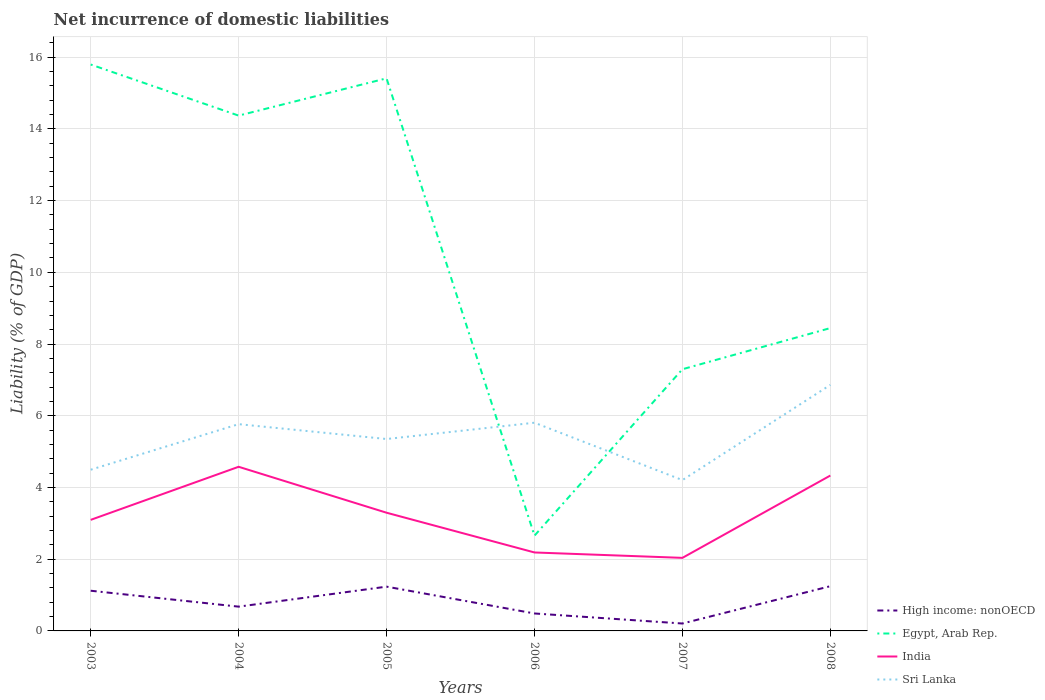Does the line corresponding to Sri Lanka intersect with the line corresponding to High income: nonOECD?
Your response must be concise. No. Across all years, what is the maximum net incurrence of domestic liabilities in High income: nonOECD?
Provide a succinct answer. 0.21. What is the total net incurrence of domestic liabilities in High income: nonOECD in the graph?
Give a very brief answer. 0.75. What is the difference between the highest and the second highest net incurrence of domestic liabilities in High income: nonOECD?
Keep it short and to the point. 1.04. What is the difference between the highest and the lowest net incurrence of domestic liabilities in India?
Offer a terse response. 3. Is the net incurrence of domestic liabilities in India strictly greater than the net incurrence of domestic liabilities in Egypt, Arab Rep. over the years?
Offer a terse response. Yes. How many lines are there?
Make the answer very short. 4. How many years are there in the graph?
Your answer should be very brief. 6. Are the values on the major ticks of Y-axis written in scientific E-notation?
Provide a succinct answer. No. Does the graph contain any zero values?
Make the answer very short. No. What is the title of the graph?
Keep it short and to the point. Net incurrence of domestic liabilities. What is the label or title of the Y-axis?
Ensure brevity in your answer.  Liability (% of GDP). What is the Liability (% of GDP) in High income: nonOECD in 2003?
Make the answer very short. 1.12. What is the Liability (% of GDP) in Egypt, Arab Rep. in 2003?
Give a very brief answer. 15.79. What is the Liability (% of GDP) of India in 2003?
Provide a short and direct response. 3.1. What is the Liability (% of GDP) of Sri Lanka in 2003?
Your answer should be compact. 4.5. What is the Liability (% of GDP) of High income: nonOECD in 2004?
Your answer should be very brief. 0.68. What is the Liability (% of GDP) of Egypt, Arab Rep. in 2004?
Provide a short and direct response. 14.37. What is the Liability (% of GDP) in India in 2004?
Your response must be concise. 4.58. What is the Liability (% of GDP) in Sri Lanka in 2004?
Give a very brief answer. 5.77. What is the Liability (% of GDP) in High income: nonOECD in 2005?
Give a very brief answer. 1.23. What is the Liability (% of GDP) in Egypt, Arab Rep. in 2005?
Provide a short and direct response. 15.41. What is the Liability (% of GDP) in India in 2005?
Make the answer very short. 3.3. What is the Liability (% of GDP) in Sri Lanka in 2005?
Provide a short and direct response. 5.35. What is the Liability (% of GDP) in High income: nonOECD in 2006?
Keep it short and to the point. 0.49. What is the Liability (% of GDP) in Egypt, Arab Rep. in 2006?
Give a very brief answer. 2.66. What is the Liability (% of GDP) of India in 2006?
Give a very brief answer. 2.19. What is the Liability (% of GDP) in Sri Lanka in 2006?
Ensure brevity in your answer.  5.81. What is the Liability (% of GDP) of High income: nonOECD in 2007?
Your response must be concise. 0.21. What is the Liability (% of GDP) of Egypt, Arab Rep. in 2007?
Provide a succinct answer. 7.3. What is the Liability (% of GDP) in India in 2007?
Offer a terse response. 2.04. What is the Liability (% of GDP) in Sri Lanka in 2007?
Offer a terse response. 4.21. What is the Liability (% of GDP) of High income: nonOECD in 2008?
Offer a terse response. 1.25. What is the Liability (% of GDP) in Egypt, Arab Rep. in 2008?
Your answer should be very brief. 8.45. What is the Liability (% of GDP) in India in 2008?
Offer a terse response. 4.33. What is the Liability (% of GDP) of Sri Lanka in 2008?
Provide a short and direct response. 6.86. Across all years, what is the maximum Liability (% of GDP) in High income: nonOECD?
Give a very brief answer. 1.25. Across all years, what is the maximum Liability (% of GDP) in Egypt, Arab Rep.?
Give a very brief answer. 15.79. Across all years, what is the maximum Liability (% of GDP) of India?
Provide a succinct answer. 4.58. Across all years, what is the maximum Liability (% of GDP) of Sri Lanka?
Offer a very short reply. 6.86. Across all years, what is the minimum Liability (% of GDP) in High income: nonOECD?
Provide a short and direct response. 0.21. Across all years, what is the minimum Liability (% of GDP) in Egypt, Arab Rep.?
Provide a short and direct response. 2.66. Across all years, what is the minimum Liability (% of GDP) of India?
Provide a succinct answer. 2.04. Across all years, what is the minimum Liability (% of GDP) in Sri Lanka?
Your response must be concise. 4.21. What is the total Liability (% of GDP) of High income: nonOECD in the graph?
Your answer should be compact. 4.97. What is the total Liability (% of GDP) of Egypt, Arab Rep. in the graph?
Make the answer very short. 63.97. What is the total Liability (% of GDP) in India in the graph?
Your answer should be compact. 19.53. What is the total Liability (% of GDP) in Sri Lanka in the graph?
Offer a terse response. 32.49. What is the difference between the Liability (% of GDP) of High income: nonOECD in 2003 and that in 2004?
Your answer should be very brief. 0.44. What is the difference between the Liability (% of GDP) in Egypt, Arab Rep. in 2003 and that in 2004?
Your answer should be compact. 1.42. What is the difference between the Liability (% of GDP) in India in 2003 and that in 2004?
Provide a succinct answer. -1.48. What is the difference between the Liability (% of GDP) of Sri Lanka in 2003 and that in 2004?
Offer a very short reply. -1.27. What is the difference between the Liability (% of GDP) of High income: nonOECD in 2003 and that in 2005?
Provide a short and direct response. -0.11. What is the difference between the Liability (% of GDP) in Egypt, Arab Rep. in 2003 and that in 2005?
Ensure brevity in your answer.  0.39. What is the difference between the Liability (% of GDP) of India in 2003 and that in 2005?
Provide a short and direct response. -0.2. What is the difference between the Liability (% of GDP) in Sri Lanka in 2003 and that in 2005?
Provide a short and direct response. -0.86. What is the difference between the Liability (% of GDP) in High income: nonOECD in 2003 and that in 2006?
Your answer should be very brief. 0.63. What is the difference between the Liability (% of GDP) in Egypt, Arab Rep. in 2003 and that in 2006?
Give a very brief answer. 13.14. What is the difference between the Liability (% of GDP) of India in 2003 and that in 2006?
Make the answer very short. 0.91. What is the difference between the Liability (% of GDP) of Sri Lanka in 2003 and that in 2006?
Your response must be concise. -1.31. What is the difference between the Liability (% of GDP) in High income: nonOECD in 2003 and that in 2007?
Ensure brevity in your answer.  0.91. What is the difference between the Liability (% of GDP) in Egypt, Arab Rep. in 2003 and that in 2007?
Ensure brevity in your answer.  8.5. What is the difference between the Liability (% of GDP) of India in 2003 and that in 2007?
Ensure brevity in your answer.  1.06. What is the difference between the Liability (% of GDP) of Sri Lanka in 2003 and that in 2007?
Offer a terse response. 0.29. What is the difference between the Liability (% of GDP) of High income: nonOECD in 2003 and that in 2008?
Your answer should be compact. -0.13. What is the difference between the Liability (% of GDP) in Egypt, Arab Rep. in 2003 and that in 2008?
Offer a very short reply. 7.35. What is the difference between the Liability (% of GDP) in India in 2003 and that in 2008?
Your answer should be very brief. -1.24. What is the difference between the Liability (% of GDP) in Sri Lanka in 2003 and that in 2008?
Make the answer very short. -2.37. What is the difference between the Liability (% of GDP) in High income: nonOECD in 2004 and that in 2005?
Your response must be concise. -0.56. What is the difference between the Liability (% of GDP) in Egypt, Arab Rep. in 2004 and that in 2005?
Make the answer very short. -1.04. What is the difference between the Liability (% of GDP) in India in 2004 and that in 2005?
Your answer should be compact. 1.28. What is the difference between the Liability (% of GDP) of Sri Lanka in 2004 and that in 2005?
Provide a short and direct response. 0.41. What is the difference between the Liability (% of GDP) in High income: nonOECD in 2004 and that in 2006?
Your response must be concise. 0.19. What is the difference between the Liability (% of GDP) of Egypt, Arab Rep. in 2004 and that in 2006?
Ensure brevity in your answer.  11.71. What is the difference between the Liability (% of GDP) in India in 2004 and that in 2006?
Offer a very short reply. 2.39. What is the difference between the Liability (% of GDP) in Sri Lanka in 2004 and that in 2006?
Keep it short and to the point. -0.04. What is the difference between the Liability (% of GDP) in High income: nonOECD in 2004 and that in 2007?
Provide a short and direct response. 0.47. What is the difference between the Liability (% of GDP) in Egypt, Arab Rep. in 2004 and that in 2007?
Ensure brevity in your answer.  7.07. What is the difference between the Liability (% of GDP) of India in 2004 and that in 2007?
Give a very brief answer. 2.54. What is the difference between the Liability (% of GDP) in Sri Lanka in 2004 and that in 2007?
Give a very brief answer. 1.56. What is the difference between the Liability (% of GDP) in High income: nonOECD in 2004 and that in 2008?
Provide a succinct answer. -0.57. What is the difference between the Liability (% of GDP) of Egypt, Arab Rep. in 2004 and that in 2008?
Ensure brevity in your answer.  5.93. What is the difference between the Liability (% of GDP) in India in 2004 and that in 2008?
Your answer should be very brief. 0.24. What is the difference between the Liability (% of GDP) of Sri Lanka in 2004 and that in 2008?
Your answer should be very brief. -1.1. What is the difference between the Liability (% of GDP) of High income: nonOECD in 2005 and that in 2006?
Offer a terse response. 0.75. What is the difference between the Liability (% of GDP) of Egypt, Arab Rep. in 2005 and that in 2006?
Give a very brief answer. 12.75. What is the difference between the Liability (% of GDP) in India in 2005 and that in 2006?
Your answer should be very brief. 1.11. What is the difference between the Liability (% of GDP) of Sri Lanka in 2005 and that in 2006?
Your answer should be very brief. -0.45. What is the difference between the Liability (% of GDP) of High income: nonOECD in 2005 and that in 2007?
Your answer should be very brief. 1.03. What is the difference between the Liability (% of GDP) in Egypt, Arab Rep. in 2005 and that in 2007?
Keep it short and to the point. 8.11. What is the difference between the Liability (% of GDP) of India in 2005 and that in 2007?
Give a very brief answer. 1.26. What is the difference between the Liability (% of GDP) of Sri Lanka in 2005 and that in 2007?
Provide a succinct answer. 1.15. What is the difference between the Liability (% of GDP) of High income: nonOECD in 2005 and that in 2008?
Ensure brevity in your answer.  -0.01. What is the difference between the Liability (% of GDP) in Egypt, Arab Rep. in 2005 and that in 2008?
Your answer should be compact. 6.96. What is the difference between the Liability (% of GDP) of India in 2005 and that in 2008?
Provide a short and direct response. -1.04. What is the difference between the Liability (% of GDP) in Sri Lanka in 2005 and that in 2008?
Offer a terse response. -1.51. What is the difference between the Liability (% of GDP) of High income: nonOECD in 2006 and that in 2007?
Make the answer very short. 0.28. What is the difference between the Liability (% of GDP) of Egypt, Arab Rep. in 2006 and that in 2007?
Offer a terse response. -4.64. What is the difference between the Liability (% of GDP) in India in 2006 and that in 2007?
Offer a very short reply. 0.15. What is the difference between the Liability (% of GDP) in High income: nonOECD in 2006 and that in 2008?
Offer a very short reply. -0.76. What is the difference between the Liability (% of GDP) of Egypt, Arab Rep. in 2006 and that in 2008?
Make the answer very short. -5.79. What is the difference between the Liability (% of GDP) of India in 2006 and that in 2008?
Your response must be concise. -2.15. What is the difference between the Liability (% of GDP) in Sri Lanka in 2006 and that in 2008?
Offer a terse response. -1.06. What is the difference between the Liability (% of GDP) of High income: nonOECD in 2007 and that in 2008?
Your response must be concise. -1.04. What is the difference between the Liability (% of GDP) of Egypt, Arab Rep. in 2007 and that in 2008?
Give a very brief answer. -1.15. What is the difference between the Liability (% of GDP) in India in 2007 and that in 2008?
Keep it short and to the point. -2.3. What is the difference between the Liability (% of GDP) in Sri Lanka in 2007 and that in 2008?
Keep it short and to the point. -2.66. What is the difference between the Liability (% of GDP) of High income: nonOECD in 2003 and the Liability (% of GDP) of Egypt, Arab Rep. in 2004?
Your answer should be compact. -13.25. What is the difference between the Liability (% of GDP) of High income: nonOECD in 2003 and the Liability (% of GDP) of India in 2004?
Keep it short and to the point. -3.46. What is the difference between the Liability (% of GDP) of High income: nonOECD in 2003 and the Liability (% of GDP) of Sri Lanka in 2004?
Make the answer very short. -4.65. What is the difference between the Liability (% of GDP) in Egypt, Arab Rep. in 2003 and the Liability (% of GDP) in India in 2004?
Provide a short and direct response. 11.22. What is the difference between the Liability (% of GDP) in Egypt, Arab Rep. in 2003 and the Liability (% of GDP) in Sri Lanka in 2004?
Give a very brief answer. 10.03. What is the difference between the Liability (% of GDP) in India in 2003 and the Liability (% of GDP) in Sri Lanka in 2004?
Make the answer very short. -2.67. What is the difference between the Liability (% of GDP) in High income: nonOECD in 2003 and the Liability (% of GDP) in Egypt, Arab Rep. in 2005?
Your answer should be very brief. -14.29. What is the difference between the Liability (% of GDP) in High income: nonOECD in 2003 and the Liability (% of GDP) in India in 2005?
Your answer should be very brief. -2.18. What is the difference between the Liability (% of GDP) of High income: nonOECD in 2003 and the Liability (% of GDP) of Sri Lanka in 2005?
Provide a succinct answer. -4.23. What is the difference between the Liability (% of GDP) in Egypt, Arab Rep. in 2003 and the Liability (% of GDP) in India in 2005?
Give a very brief answer. 12.5. What is the difference between the Liability (% of GDP) of Egypt, Arab Rep. in 2003 and the Liability (% of GDP) of Sri Lanka in 2005?
Ensure brevity in your answer.  10.44. What is the difference between the Liability (% of GDP) in India in 2003 and the Liability (% of GDP) in Sri Lanka in 2005?
Provide a short and direct response. -2.25. What is the difference between the Liability (% of GDP) of High income: nonOECD in 2003 and the Liability (% of GDP) of Egypt, Arab Rep. in 2006?
Your response must be concise. -1.54. What is the difference between the Liability (% of GDP) of High income: nonOECD in 2003 and the Liability (% of GDP) of India in 2006?
Offer a terse response. -1.07. What is the difference between the Liability (% of GDP) of High income: nonOECD in 2003 and the Liability (% of GDP) of Sri Lanka in 2006?
Offer a terse response. -4.69. What is the difference between the Liability (% of GDP) in Egypt, Arab Rep. in 2003 and the Liability (% of GDP) in India in 2006?
Your response must be concise. 13.61. What is the difference between the Liability (% of GDP) of Egypt, Arab Rep. in 2003 and the Liability (% of GDP) of Sri Lanka in 2006?
Your response must be concise. 9.99. What is the difference between the Liability (% of GDP) of India in 2003 and the Liability (% of GDP) of Sri Lanka in 2006?
Your response must be concise. -2.71. What is the difference between the Liability (% of GDP) in High income: nonOECD in 2003 and the Liability (% of GDP) in Egypt, Arab Rep. in 2007?
Offer a terse response. -6.18. What is the difference between the Liability (% of GDP) in High income: nonOECD in 2003 and the Liability (% of GDP) in India in 2007?
Provide a succinct answer. -0.92. What is the difference between the Liability (% of GDP) in High income: nonOECD in 2003 and the Liability (% of GDP) in Sri Lanka in 2007?
Make the answer very short. -3.09. What is the difference between the Liability (% of GDP) of Egypt, Arab Rep. in 2003 and the Liability (% of GDP) of India in 2007?
Keep it short and to the point. 13.76. What is the difference between the Liability (% of GDP) in Egypt, Arab Rep. in 2003 and the Liability (% of GDP) in Sri Lanka in 2007?
Your answer should be compact. 11.59. What is the difference between the Liability (% of GDP) of India in 2003 and the Liability (% of GDP) of Sri Lanka in 2007?
Make the answer very short. -1.11. What is the difference between the Liability (% of GDP) in High income: nonOECD in 2003 and the Liability (% of GDP) in Egypt, Arab Rep. in 2008?
Ensure brevity in your answer.  -7.32. What is the difference between the Liability (% of GDP) of High income: nonOECD in 2003 and the Liability (% of GDP) of India in 2008?
Make the answer very short. -3.21. What is the difference between the Liability (% of GDP) of High income: nonOECD in 2003 and the Liability (% of GDP) of Sri Lanka in 2008?
Offer a terse response. -5.74. What is the difference between the Liability (% of GDP) in Egypt, Arab Rep. in 2003 and the Liability (% of GDP) in India in 2008?
Give a very brief answer. 11.46. What is the difference between the Liability (% of GDP) in Egypt, Arab Rep. in 2003 and the Liability (% of GDP) in Sri Lanka in 2008?
Make the answer very short. 8.93. What is the difference between the Liability (% of GDP) in India in 2003 and the Liability (% of GDP) in Sri Lanka in 2008?
Give a very brief answer. -3.76. What is the difference between the Liability (% of GDP) in High income: nonOECD in 2004 and the Liability (% of GDP) in Egypt, Arab Rep. in 2005?
Ensure brevity in your answer.  -14.73. What is the difference between the Liability (% of GDP) of High income: nonOECD in 2004 and the Liability (% of GDP) of India in 2005?
Ensure brevity in your answer.  -2.62. What is the difference between the Liability (% of GDP) of High income: nonOECD in 2004 and the Liability (% of GDP) of Sri Lanka in 2005?
Your response must be concise. -4.67. What is the difference between the Liability (% of GDP) of Egypt, Arab Rep. in 2004 and the Liability (% of GDP) of India in 2005?
Your answer should be compact. 11.07. What is the difference between the Liability (% of GDP) in Egypt, Arab Rep. in 2004 and the Liability (% of GDP) in Sri Lanka in 2005?
Ensure brevity in your answer.  9.02. What is the difference between the Liability (% of GDP) in India in 2004 and the Liability (% of GDP) in Sri Lanka in 2005?
Your answer should be very brief. -0.77. What is the difference between the Liability (% of GDP) in High income: nonOECD in 2004 and the Liability (% of GDP) in Egypt, Arab Rep. in 2006?
Your answer should be very brief. -1.98. What is the difference between the Liability (% of GDP) in High income: nonOECD in 2004 and the Liability (% of GDP) in India in 2006?
Offer a very short reply. -1.51. What is the difference between the Liability (% of GDP) in High income: nonOECD in 2004 and the Liability (% of GDP) in Sri Lanka in 2006?
Offer a very short reply. -5.13. What is the difference between the Liability (% of GDP) in Egypt, Arab Rep. in 2004 and the Liability (% of GDP) in India in 2006?
Your answer should be very brief. 12.18. What is the difference between the Liability (% of GDP) of Egypt, Arab Rep. in 2004 and the Liability (% of GDP) of Sri Lanka in 2006?
Ensure brevity in your answer.  8.56. What is the difference between the Liability (% of GDP) in India in 2004 and the Liability (% of GDP) in Sri Lanka in 2006?
Your answer should be very brief. -1.23. What is the difference between the Liability (% of GDP) of High income: nonOECD in 2004 and the Liability (% of GDP) of Egypt, Arab Rep. in 2007?
Give a very brief answer. -6.62. What is the difference between the Liability (% of GDP) of High income: nonOECD in 2004 and the Liability (% of GDP) of India in 2007?
Your answer should be compact. -1.36. What is the difference between the Liability (% of GDP) of High income: nonOECD in 2004 and the Liability (% of GDP) of Sri Lanka in 2007?
Offer a very short reply. -3.53. What is the difference between the Liability (% of GDP) of Egypt, Arab Rep. in 2004 and the Liability (% of GDP) of India in 2007?
Your answer should be very brief. 12.33. What is the difference between the Liability (% of GDP) of Egypt, Arab Rep. in 2004 and the Liability (% of GDP) of Sri Lanka in 2007?
Offer a terse response. 10.16. What is the difference between the Liability (% of GDP) of India in 2004 and the Liability (% of GDP) of Sri Lanka in 2007?
Offer a terse response. 0.37. What is the difference between the Liability (% of GDP) in High income: nonOECD in 2004 and the Liability (% of GDP) in Egypt, Arab Rep. in 2008?
Ensure brevity in your answer.  -7.77. What is the difference between the Liability (% of GDP) in High income: nonOECD in 2004 and the Liability (% of GDP) in India in 2008?
Ensure brevity in your answer.  -3.66. What is the difference between the Liability (% of GDP) in High income: nonOECD in 2004 and the Liability (% of GDP) in Sri Lanka in 2008?
Give a very brief answer. -6.18. What is the difference between the Liability (% of GDP) of Egypt, Arab Rep. in 2004 and the Liability (% of GDP) of India in 2008?
Offer a very short reply. 10.04. What is the difference between the Liability (% of GDP) in Egypt, Arab Rep. in 2004 and the Liability (% of GDP) in Sri Lanka in 2008?
Provide a succinct answer. 7.51. What is the difference between the Liability (% of GDP) in India in 2004 and the Liability (% of GDP) in Sri Lanka in 2008?
Give a very brief answer. -2.28. What is the difference between the Liability (% of GDP) of High income: nonOECD in 2005 and the Liability (% of GDP) of Egypt, Arab Rep. in 2006?
Offer a terse response. -1.42. What is the difference between the Liability (% of GDP) in High income: nonOECD in 2005 and the Liability (% of GDP) in India in 2006?
Offer a terse response. -0.95. What is the difference between the Liability (% of GDP) in High income: nonOECD in 2005 and the Liability (% of GDP) in Sri Lanka in 2006?
Your answer should be very brief. -4.57. What is the difference between the Liability (% of GDP) in Egypt, Arab Rep. in 2005 and the Liability (% of GDP) in India in 2006?
Ensure brevity in your answer.  13.22. What is the difference between the Liability (% of GDP) of Egypt, Arab Rep. in 2005 and the Liability (% of GDP) of Sri Lanka in 2006?
Offer a terse response. 9.6. What is the difference between the Liability (% of GDP) in India in 2005 and the Liability (% of GDP) in Sri Lanka in 2006?
Provide a succinct answer. -2.51. What is the difference between the Liability (% of GDP) of High income: nonOECD in 2005 and the Liability (% of GDP) of Egypt, Arab Rep. in 2007?
Your answer should be very brief. -6.06. What is the difference between the Liability (% of GDP) in High income: nonOECD in 2005 and the Liability (% of GDP) in India in 2007?
Your response must be concise. -0.8. What is the difference between the Liability (% of GDP) in High income: nonOECD in 2005 and the Liability (% of GDP) in Sri Lanka in 2007?
Your response must be concise. -2.97. What is the difference between the Liability (% of GDP) in Egypt, Arab Rep. in 2005 and the Liability (% of GDP) in India in 2007?
Ensure brevity in your answer.  13.37. What is the difference between the Liability (% of GDP) of Egypt, Arab Rep. in 2005 and the Liability (% of GDP) of Sri Lanka in 2007?
Give a very brief answer. 11.2. What is the difference between the Liability (% of GDP) of India in 2005 and the Liability (% of GDP) of Sri Lanka in 2007?
Give a very brief answer. -0.91. What is the difference between the Liability (% of GDP) in High income: nonOECD in 2005 and the Liability (% of GDP) in Egypt, Arab Rep. in 2008?
Keep it short and to the point. -7.21. What is the difference between the Liability (% of GDP) of High income: nonOECD in 2005 and the Liability (% of GDP) of India in 2008?
Your answer should be very brief. -3.1. What is the difference between the Liability (% of GDP) of High income: nonOECD in 2005 and the Liability (% of GDP) of Sri Lanka in 2008?
Your answer should be very brief. -5.63. What is the difference between the Liability (% of GDP) in Egypt, Arab Rep. in 2005 and the Liability (% of GDP) in India in 2008?
Ensure brevity in your answer.  11.08. What is the difference between the Liability (% of GDP) in Egypt, Arab Rep. in 2005 and the Liability (% of GDP) in Sri Lanka in 2008?
Offer a very short reply. 8.55. What is the difference between the Liability (% of GDP) in India in 2005 and the Liability (% of GDP) in Sri Lanka in 2008?
Make the answer very short. -3.56. What is the difference between the Liability (% of GDP) in High income: nonOECD in 2006 and the Liability (% of GDP) in Egypt, Arab Rep. in 2007?
Give a very brief answer. -6.81. What is the difference between the Liability (% of GDP) of High income: nonOECD in 2006 and the Liability (% of GDP) of India in 2007?
Your response must be concise. -1.55. What is the difference between the Liability (% of GDP) in High income: nonOECD in 2006 and the Liability (% of GDP) in Sri Lanka in 2007?
Ensure brevity in your answer.  -3.72. What is the difference between the Liability (% of GDP) in Egypt, Arab Rep. in 2006 and the Liability (% of GDP) in India in 2007?
Your answer should be compact. 0.62. What is the difference between the Liability (% of GDP) in Egypt, Arab Rep. in 2006 and the Liability (% of GDP) in Sri Lanka in 2007?
Your answer should be very brief. -1.55. What is the difference between the Liability (% of GDP) in India in 2006 and the Liability (% of GDP) in Sri Lanka in 2007?
Offer a very short reply. -2.02. What is the difference between the Liability (% of GDP) in High income: nonOECD in 2006 and the Liability (% of GDP) in Egypt, Arab Rep. in 2008?
Offer a terse response. -7.96. What is the difference between the Liability (% of GDP) in High income: nonOECD in 2006 and the Liability (% of GDP) in India in 2008?
Keep it short and to the point. -3.85. What is the difference between the Liability (% of GDP) of High income: nonOECD in 2006 and the Liability (% of GDP) of Sri Lanka in 2008?
Provide a succinct answer. -6.37. What is the difference between the Liability (% of GDP) in Egypt, Arab Rep. in 2006 and the Liability (% of GDP) in India in 2008?
Your answer should be compact. -1.68. What is the difference between the Liability (% of GDP) of Egypt, Arab Rep. in 2006 and the Liability (% of GDP) of Sri Lanka in 2008?
Give a very brief answer. -4.2. What is the difference between the Liability (% of GDP) in India in 2006 and the Liability (% of GDP) in Sri Lanka in 2008?
Keep it short and to the point. -4.67. What is the difference between the Liability (% of GDP) in High income: nonOECD in 2007 and the Liability (% of GDP) in Egypt, Arab Rep. in 2008?
Your answer should be very brief. -8.24. What is the difference between the Liability (% of GDP) of High income: nonOECD in 2007 and the Liability (% of GDP) of India in 2008?
Offer a very short reply. -4.13. What is the difference between the Liability (% of GDP) in High income: nonOECD in 2007 and the Liability (% of GDP) in Sri Lanka in 2008?
Offer a very short reply. -6.65. What is the difference between the Liability (% of GDP) in Egypt, Arab Rep. in 2007 and the Liability (% of GDP) in India in 2008?
Provide a succinct answer. 2.96. What is the difference between the Liability (% of GDP) of Egypt, Arab Rep. in 2007 and the Liability (% of GDP) of Sri Lanka in 2008?
Your answer should be very brief. 0.44. What is the difference between the Liability (% of GDP) of India in 2007 and the Liability (% of GDP) of Sri Lanka in 2008?
Ensure brevity in your answer.  -4.82. What is the average Liability (% of GDP) in High income: nonOECD per year?
Your response must be concise. 0.83. What is the average Liability (% of GDP) in Egypt, Arab Rep. per year?
Give a very brief answer. 10.66. What is the average Liability (% of GDP) of India per year?
Provide a succinct answer. 3.25. What is the average Liability (% of GDP) of Sri Lanka per year?
Your answer should be compact. 5.41. In the year 2003, what is the difference between the Liability (% of GDP) of High income: nonOECD and Liability (% of GDP) of Egypt, Arab Rep.?
Keep it short and to the point. -14.67. In the year 2003, what is the difference between the Liability (% of GDP) of High income: nonOECD and Liability (% of GDP) of India?
Offer a very short reply. -1.98. In the year 2003, what is the difference between the Liability (% of GDP) in High income: nonOECD and Liability (% of GDP) in Sri Lanka?
Your answer should be very brief. -3.37. In the year 2003, what is the difference between the Liability (% of GDP) in Egypt, Arab Rep. and Liability (% of GDP) in India?
Your response must be concise. 12.7. In the year 2003, what is the difference between the Liability (% of GDP) of Egypt, Arab Rep. and Liability (% of GDP) of Sri Lanka?
Your answer should be very brief. 11.3. In the year 2003, what is the difference between the Liability (% of GDP) in India and Liability (% of GDP) in Sri Lanka?
Ensure brevity in your answer.  -1.4. In the year 2004, what is the difference between the Liability (% of GDP) of High income: nonOECD and Liability (% of GDP) of Egypt, Arab Rep.?
Make the answer very short. -13.69. In the year 2004, what is the difference between the Liability (% of GDP) of High income: nonOECD and Liability (% of GDP) of India?
Your response must be concise. -3.9. In the year 2004, what is the difference between the Liability (% of GDP) in High income: nonOECD and Liability (% of GDP) in Sri Lanka?
Offer a very short reply. -5.09. In the year 2004, what is the difference between the Liability (% of GDP) of Egypt, Arab Rep. and Liability (% of GDP) of India?
Keep it short and to the point. 9.79. In the year 2004, what is the difference between the Liability (% of GDP) in Egypt, Arab Rep. and Liability (% of GDP) in Sri Lanka?
Give a very brief answer. 8.6. In the year 2004, what is the difference between the Liability (% of GDP) of India and Liability (% of GDP) of Sri Lanka?
Your response must be concise. -1.19. In the year 2005, what is the difference between the Liability (% of GDP) of High income: nonOECD and Liability (% of GDP) of Egypt, Arab Rep.?
Make the answer very short. -14.17. In the year 2005, what is the difference between the Liability (% of GDP) in High income: nonOECD and Liability (% of GDP) in India?
Your answer should be very brief. -2.06. In the year 2005, what is the difference between the Liability (% of GDP) in High income: nonOECD and Liability (% of GDP) in Sri Lanka?
Offer a terse response. -4.12. In the year 2005, what is the difference between the Liability (% of GDP) in Egypt, Arab Rep. and Liability (% of GDP) in India?
Your answer should be very brief. 12.11. In the year 2005, what is the difference between the Liability (% of GDP) in Egypt, Arab Rep. and Liability (% of GDP) in Sri Lanka?
Offer a terse response. 10.06. In the year 2005, what is the difference between the Liability (% of GDP) of India and Liability (% of GDP) of Sri Lanka?
Offer a very short reply. -2.06. In the year 2006, what is the difference between the Liability (% of GDP) in High income: nonOECD and Liability (% of GDP) in Egypt, Arab Rep.?
Ensure brevity in your answer.  -2.17. In the year 2006, what is the difference between the Liability (% of GDP) of High income: nonOECD and Liability (% of GDP) of India?
Your answer should be very brief. -1.7. In the year 2006, what is the difference between the Liability (% of GDP) of High income: nonOECD and Liability (% of GDP) of Sri Lanka?
Your answer should be very brief. -5.32. In the year 2006, what is the difference between the Liability (% of GDP) of Egypt, Arab Rep. and Liability (% of GDP) of India?
Your answer should be very brief. 0.47. In the year 2006, what is the difference between the Liability (% of GDP) in Egypt, Arab Rep. and Liability (% of GDP) in Sri Lanka?
Your answer should be compact. -3.15. In the year 2006, what is the difference between the Liability (% of GDP) of India and Liability (% of GDP) of Sri Lanka?
Offer a terse response. -3.62. In the year 2007, what is the difference between the Liability (% of GDP) of High income: nonOECD and Liability (% of GDP) of Egypt, Arab Rep.?
Keep it short and to the point. -7.09. In the year 2007, what is the difference between the Liability (% of GDP) of High income: nonOECD and Liability (% of GDP) of India?
Offer a very short reply. -1.83. In the year 2007, what is the difference between the Liability (% of GDP) of High income: nonOECD and Liability (% of GDP) of Sri Lanka?
Keep it short and to the point. -4. In the year 2007, what is the difference between the Liability (% of GDP) of Egypt, Arab Rep. and Liability (% of GDP) of India?
Your answer should be compact. 5.26. In the year 2007, what is the difference between the Liability (% of GDP) of Egypt, Arab Rep. and Liability (% of GDP) of Sri Lanka?
Ensure brevity in your answer.  3.09. In the year 2007, what is the difference between the Liability (% of GDP) in India and Liability (% of GDP) in Sri Lanka?
Provide a succinct answer. -2.17. In the year 2008, what is the difference between the Liability (% of GDP) of High income: nonOECD and Liability (% of GDP) of Egypt, Arab Rep.?
Give a very brief answer. -7.2. In the year 2008, what is the difference between the Liability (% of GDP) of High income: nonOECD and Liability (% of GDP) of India?
Your response must be concise. -3.09. In the year 2008, what is the difference between the Liability (% of GDP) of High income: nonOECD and Liability (% of GDP) of Sri Lanka?
Your answer should be very brief. -5.61. In the year 2008, what is the difference between the Liability (% of GDP) of Egypt, Arab Rep. and Liability (% of GDP) of India?
Offer a very short reply. 4.11. In the year 2008, what is the difference between the Liability (% of GDP) of Egypt, Arab Rep. and Liability (% of GDP) of Sri Lanka?
Offer a very short reply. 1.58. In the year 2008, what is the difference between the Liability (% of GDP) of India and Liability (% of GDP) of Sri Lanka?
Offer a very short reply. -2.53. What is the ratio of the Liability (% of GDP) of High income: nonOECD in 2003 to that in 2004?
Offer a terse response. 1.66. What is the ratio of the Liability (% of GDP) in Egypt, Arab Rep. in 2003 to that in 2004?
Offer a very short reply. 1.1. What is the ratio of the Liability (% of GDP) in India in 2003 to that in 2004?
Provide a short and direct response. 0.68. What is the ratio of the Liability (% of GDP) of Sri Lanka in 2003 to that in 2004?
Give a very brief answer. 0.78. What is the ratio of the Liability (% of GDP) in High income: nonOECD in 2003 to that in 2005?
Ensure brevity in your answer.  0.91. What is the ratio of the Liability (% of GDP) of India in 2003 to that in 2005?
Make the answer very short. 0.94. What is the ratio of the Liability (% of GDP) in Sri Lanka in 2003 to that in 2005?
Provide a short and direct response. 0.84. What is the ratio of the Liability (% of GDP) of High income: nonOECD in 2003 to that in 2006?
Give a very brief answer. 2.3. What is the ratio of the Liability (% of GDP) in Egypt, Arab Rep. in 2003 to that in 2006?
Provide a succinct answer. 5.95. What is the ratio of the Liability (% of GDP) in India in 2003 to that in 2006?
Your answer should be compact. 1.42. What is the ratio of the Liability (% of GDP) of Sri Lanka in 2003 to that in 2006?
Your answer should be compact. 0.77. What is the ratio of the Liability (% of GDP) of High income: nonOECD in 2003 to that in 2007?
Provide a short and direct response. 5.42. What is the ratio of the Liability (% of GDP) in Egypt, Arab Rep. in 2003 to that in 2007?
Offer a terse response. 2.16. What is the ratio of the Liability (% of GDP) in India in 2003 to that in 2007?
Your response must be concise. 1.52. What is the ratio of the Liability (% of GDP) in Sri Lanka in 2003 to that in 2007?
Your answer should be very brief. 1.07. What is the ratio of the Liability (% of GDP) of High income: nonOECD in 2003 to that in 2008?
Ensure brevity in your answer.  0.9. What is the ratio of the Liability (% of GDP) of Egypt, Arab Rep. in 2003 to that in 2008?
Give a very brief answer. 1.87. What is the ratio of the Liability (% of GDP) of India in 2003 to that in 2008?
Make the answer very short. 0.71. What is the ratio of the Liability (% of GDP) in Sri Lanka in 2003 to that in 2008?
Provide a succinct answer. 0.66. What is the ratio of the Liability (% of GDP) of High income: nonOECD in 2004 to that in 2005?
Your response must be concise. 0.55. What is the ratio of the Liability (% of GDP) of Egypt, Arab Rep. in 2004 to that in 2005?
Your response must be concise. 0.93. What is the ratio of the Liability (% of GDP) in India in 2004 to that in 2005?
Your response must be concise. 1.39. What is the ratio of the Liability (% of GDP) of Sri Lanka in 2004 to that in 2005?
Provide a succinct answer. 1.08. What is the ratio of the Liability (% of GDP) of High income: nonOECD in 2004 to that in 2006?
Provide a short and direct response. 1.39. What is the ratio of the Liability (% of GDP) in Egypt, Arab Rep. in 2004 to that in 2006?
Ensure brevity in your answer.  5.41. What is the ratio of the Liability (% of GDP) of India in 2004 to that in 2006?
Provide a short and direct response. 2.09. What is the ratio of the Liability (% of GDP) in Sri Lanka in 2004 to that in 2006?
Offer a terse response. 0.99. What is the ratio of the Liability (% of GDP) in High income: nonOECD in 2004 to that in 2007?
Offer a very short reply. 3.28. What is the ratio of the Liability (% of GDP) in Egypt, Arab Rep. in 2004 to that in 2007?
Keep it short and to the point. 1.97. What is the ratio of the Liability (% of GDP) of India in 2004 to that in 2007?
Keep it short and to the point. 2.25. What is the ratio of the Liability (% of GDP) in Sri Lanka in 2004 to that in 2007?
Make the answer very short. 1.37. What is the ratio of the Liability (% of GDP) of High income: nonOECD in 2004 to that in 2008?
Your response must be concise. 0.54. What is the ratio of the Liability (% of GDP) of Egypt, Arab Rep. in 2004 to that in 2008?
Offer a very short reply. 1.7. What is the ratio of the Liability (% of GDP) of India in 2004 to that in 2008?
Give a very brief answer. 1.06. What is the ratio of the Liability (% of GDP) in Sri Lanka in 2004 to that in 2008?
Keep it short and to the point. 0.84. What is the ratio of the Liability (% of GDP) of High income: nonOECD in 2005 to that in 2006?
Provide a short and direct response. 2.54. What is the ratio of the Liability (% of GDP) of Egypt, Arab Rep. in 2005 to that in 2006?
Provide a succinct answer. 5.8. What is the ratio of the Liability (% of GDP) of India in 2005 to that in 2006?
Your answer should be very brief. 1.51. What is the ratio of the Liability (% of GDP) in Sri Lanka in 2005 to that in 2006?
Give a very brief answer. 0.92. What is the ratio of the Liability (% of GDP) in High income: nonOECD in 2005 to that in 2007?
Give a very brief answer. 5.97. What is the ratio of the Liability (% of GDP) of Egypt, Arab Rep. in 2005 to that in 2007?
Ensure brevity in your answer.  2.11. What is the ratio of the Liability (% of GDP) in India in 2005 to that in 2007?
Your answer should be very brief. 1.62. What is the ratio of the Liability (% of GDP) of Sri Lanka in 2005 to that in 2007?
Your response must be concise. 1.27. What is the ratio of the Liability (% of GDP) of High income: nonOECD in 2005 to that in 2008?
Keep it short and to the point. 0.99. What is the ratio of the Liability (% of GDP) in Egypt, Arab Rep. in 2005 to that in 2008?
Your answer should be compact. 1.82. What is the ratio of the Liability (% of GDP) in India in 2005 to that in 2008?
Make the answer very short. 0.76. What is the ratio of the Liability (% of GDP) in Sri Lanka in 2005 to that in 2008?
Keep it short and to the point. 0.78. What is the ratio of the Liability (% of GDP) in High income: nonOECD in 2006 to that in 2007?
Provide a succinct answer. 2.36. What is the ratio of the Liability (% of GDP) of Egypt, Arab Rep. in 2006 to that in 2007?
Make the answer very short. 0.36. What is the ratio of the Liability (% of GDP) in India in 2006 to that in 2007?
Keep it short and to the point. 1.07. What is the ratio of the Liability (% of GDP) of Sri Lanka in 2006 to that in 2007?
Keep it short and to the point. 1.38. What is the ratio of the Liability (% of GDP) in High income: nonOECD in 2006 to that in 2008?
Provide a succinct answer. 0.39. What is the ratio of the Liability (% of GDP) of Egypt, Arab Rep. in 2006 to that in 2008?
Offer a very short reply. 0.31. What is the ratio of the Liability (% of GDP) in India in 2006 to that in 2008?
Offer a very short reply. 0.5. What is the ratio of the Liability (% of GDP) of Sri Lanka in 2006 to that in 2008?
Your response must be concise. 0.85. What is the ratio of the Liability (% of GDP) of High income: nonOECD in 2007 to that in 2008?
Make the answer very short. 0.17. What is the ratio of the Liability (% of GDP) of Egypt, Arab Rep. in 2007 to that in 2008?
Ensure brevity in your answer.  0.86. What is the ratio of the Liability (% of GDP) of India in 2007 to that in 2008?
Your response must be concise. 0.47. What is the ratio of the Liability (% of GDP) of Sri Lanka in 2007 to that in 2008?
Your response must be concise. 0.61. What is the difference between the highest and the second highest Liability (% of GDP) in High income: nonOECD?
Provide a succinct answer. 0.01. What is the difference between the highest and the second highest Liability (% of GDP) of Egypt, Arab Rep.?
Provide a succinct answer. 0.39. What is the difference between the highest and the second highest Liability (% of GDP) of India?
Your answer should be compact. 0.24. What is the difference between the highest and the second highest Liability (% of GDP) in Sri Lanka?
Offer a very short reply. 1.06. What is the difference between the highest and the lowest Liability (% of GDP) in High income: nonOECD?
Provide a short and direct response. 1.04. What is the difference between the highest and the lowest Liability (% of GDP) of Egypt, Arab Rep.?
Your response must be concise. 13.14. What is the difference between the highest and the lowest Liability (% of GDP) in India?
Provide a succinct answer. 2.54. What is the difference between the highest and the lowest Liability (% of GDP) in Sri Lanka?
Offer a terse response. 2.66. 